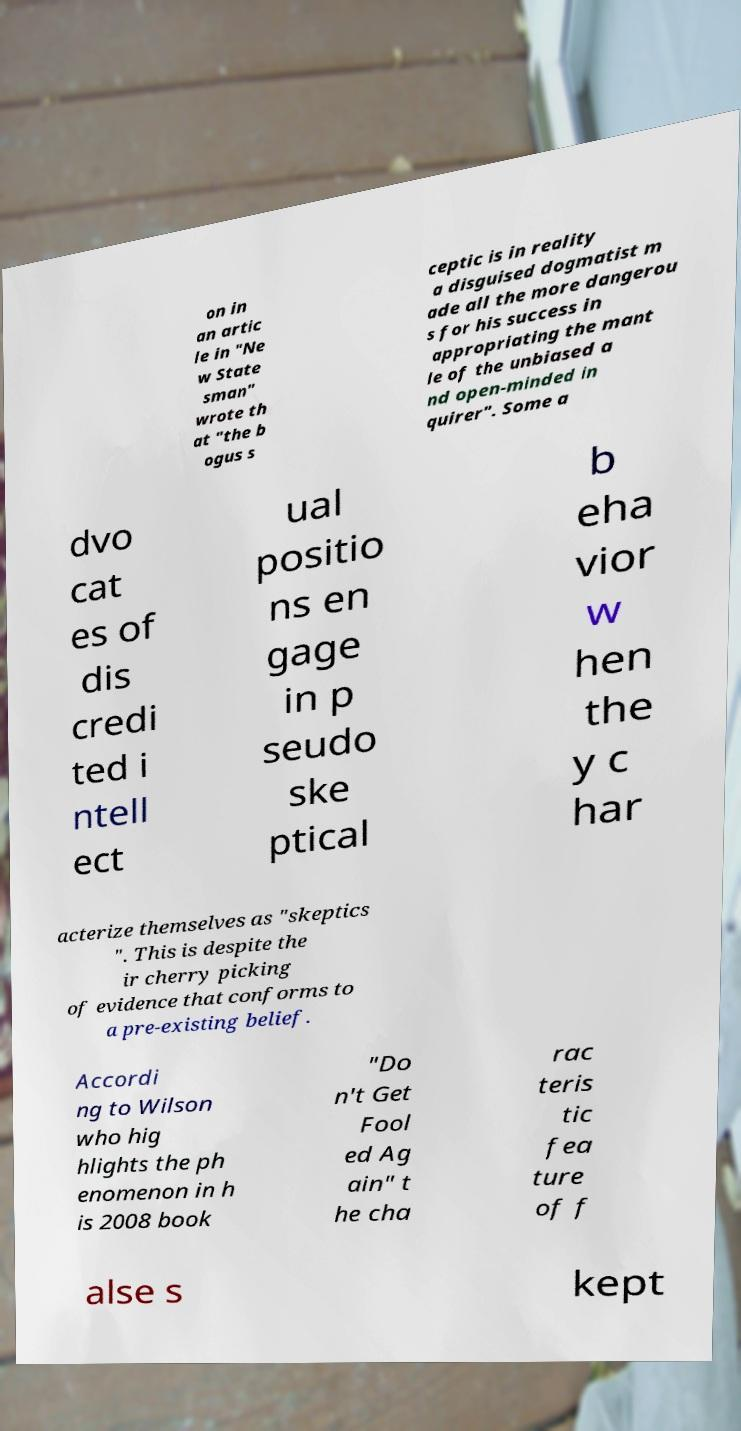For documentation purposes, I need the text within this image transcribed. Could you provide that? on in an artic le in "Ne w State sman" wrote th at "the b ogus s ceptic is in reality a disguised dogmatist m ade all the more dangerou s for his success in appropriating the mant le of the unbiased a nd open-minded in quirer". Some a dvo cat es of dis credi ted i ntell ect ual positio ns en gage in p seudo ske ptical b eha vior w hen the y c har acterize themselves as "skeptics ". This is despite the ir cherry picking of evidence that conforms to a pre-existing belief. Accordi ng to Wilson who hig hlights the ph enomenon in h is 2008 book "Do n't Get Fool ed Ag ain" t he cha rac teris tic fea ture of f alse s kept 